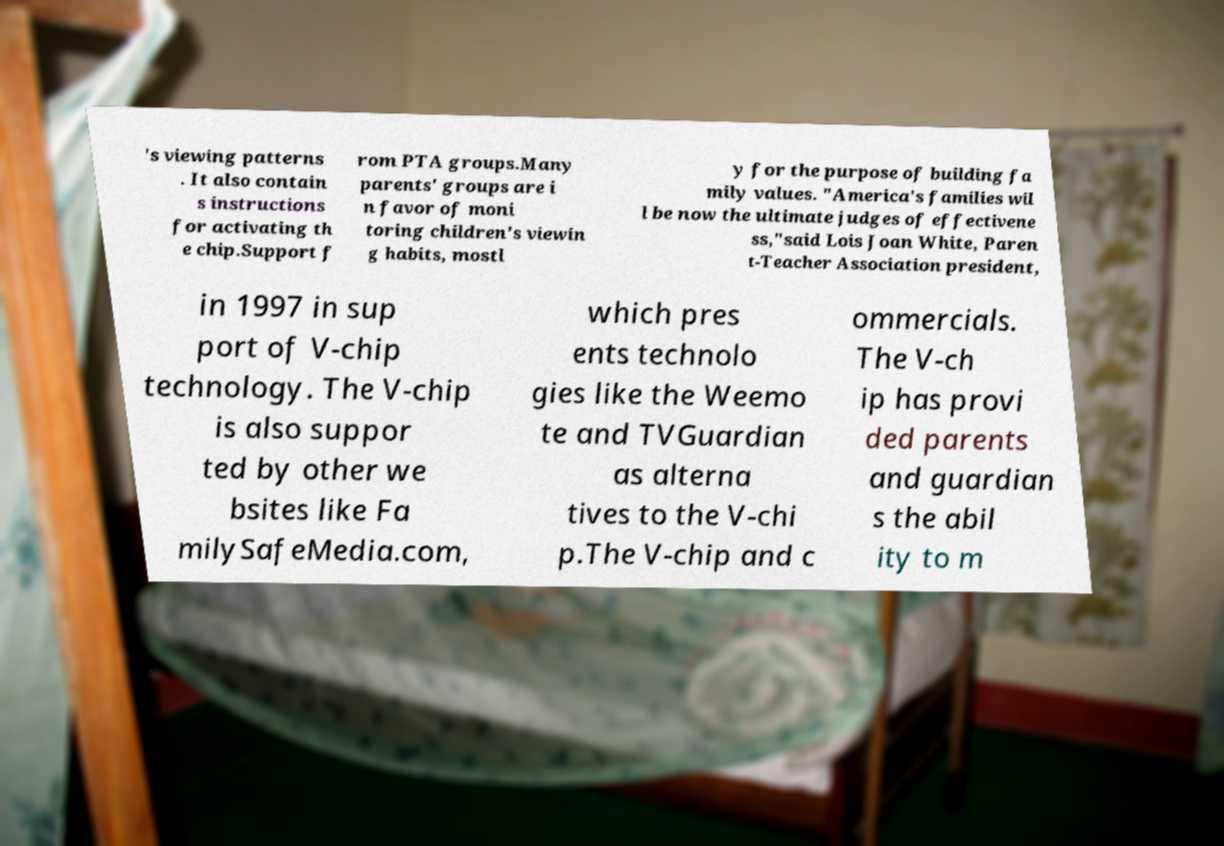There's text embedded in this image that I need extracted. Can you transcribe it verbatim? 's viewing patterns . It also contain s instructions for activating th e chip.Support f rom PTA groups.Many parents' groups are i n favor of moni toring children's viewin g habits, mostl y for the purpose of building fa mily values. "America's families wil l be now the ultimate judges of effectivene ss,"said Lois Joan White, Paren t-Teacher Association president, in 1997 in sup port of V-chip technology. The V-chip is also suppor ted by other we bsites like Fa milySafeMedia.com, which pres ents technolo gies like the Weemo te and TVGuardian as alterna tives to the V-chi p.The V-chip and c ommercials. The V-ch ip has provi ded parents and guardian s the abil ity to m 